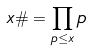<formula> <loc_0><loc_0><loc_500><loc_500>x \# = \prod _ { p \leq x } p</formula> 